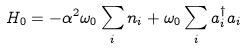Convert formula to latex. <formula><loc_0><loc_0><loc_500><loc_500>H _ { 0 } = - \alpha ^ { 2 } \omega _ { 0 } \sum _ { i } n _ { i } + \omega _ { 0 } \sum _ { i } a ^ { \dagger } _ { i } a _ { i }</formula> 